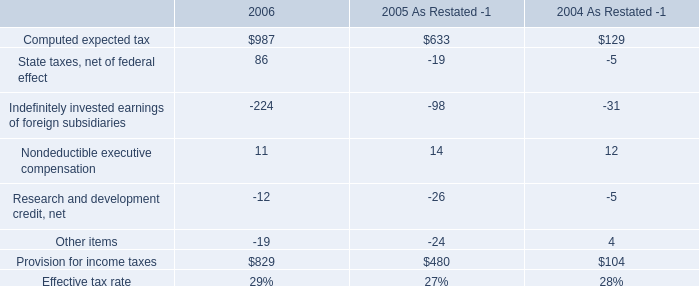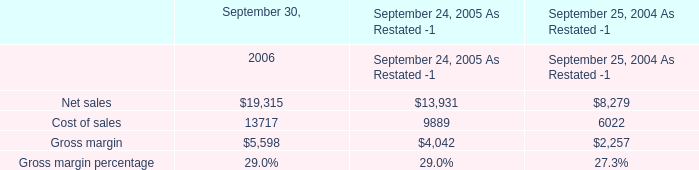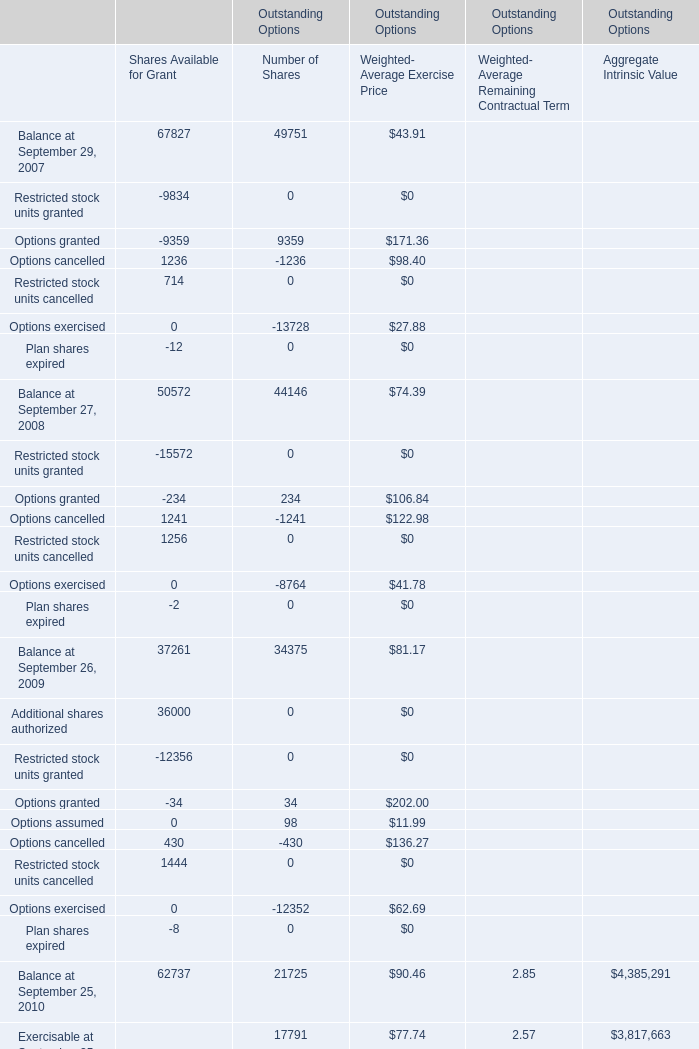What's the sum of Cost of sales of September 30, 2006, Options granted of Outstanding Options Number of Shares, and Additional shares authorized of Outstanding Options Shares Available for Grant ? 
Computations: ((13717.0 + 9359.0) + 36000.0)
Answer: 59076.0. 